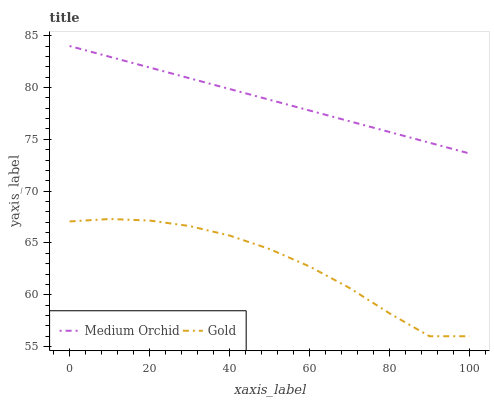Does Gold have the minimum area under the curve?
Answer yes or no. Yes. Does Medium Orchid have the maximum area under the curve?
Answer yes or no. Yes. Does Gold have the maximum area under the curve?
Answer yes or no. No. Is Medium Orchid the smoothest?
Answer yes or no. Yes. Is Gold the roughest?
Answer yes or no. Yes. Is Gold the smoothest?
Answer yes or no. No. Does Gold have the lowest value?
Answer yes or no. Yes. Does Medium Orchid have the highest value?
Answer yes or no. Yes. Does Gold have the highest value?
Answer yes or no. No. Is Gold less than Medium Orchid?
Answer yes or no. Yes. Is Medium Orchid greater than Gold?
Answer yes or no. Yes. Does Gold intersect Medium Orchid?
Answer yes or no. No. 